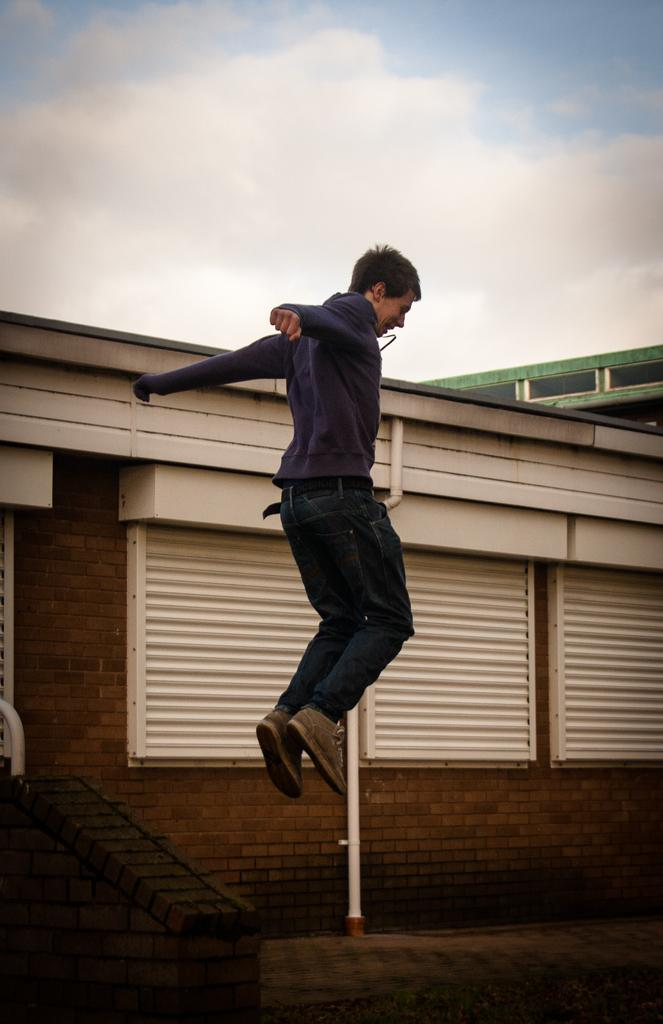What is the main subject in the foreground of the image? There is a man in the air in the foreground of the image. What can be seen in the background of the image? There is a building in the background of the image. What is visible at the top of the image? The sky is visible at the top of the image. What can be observed in the sky? Clouds are present in the sky. Where is the pot located in the image? There is no pot present in the image. Can you tell me the total amount on the receipt in the image? There is no receipt present in the image. 